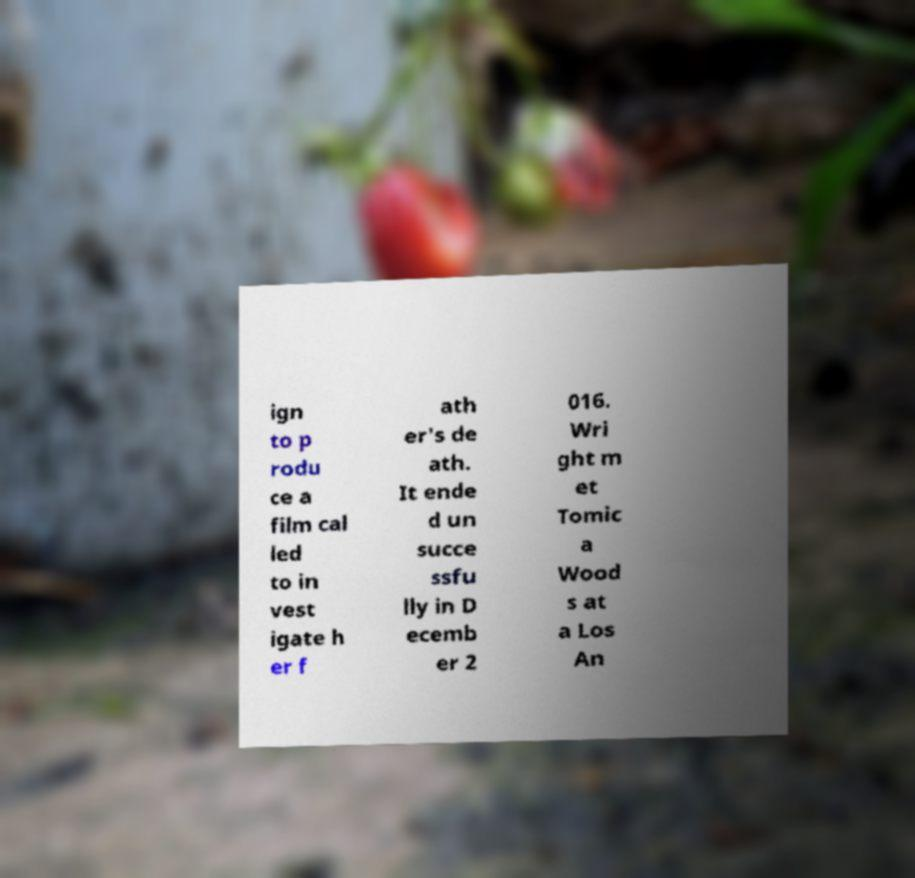Please read and relay the text visible in this image. What does it say? ign to p rodu ce a film cal led to in vest igate h er f ath er's de ath. It ende d un succe ssfu lly in D ecemb er 2 016. Wri ght m et Tomic a Wood s at a Los An 